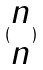Convert formula to latex. <formula><loc_0><loc_0><loc_500><loc_500>( \begin{matrix} n \\ n \end{matrix} )</formula> 